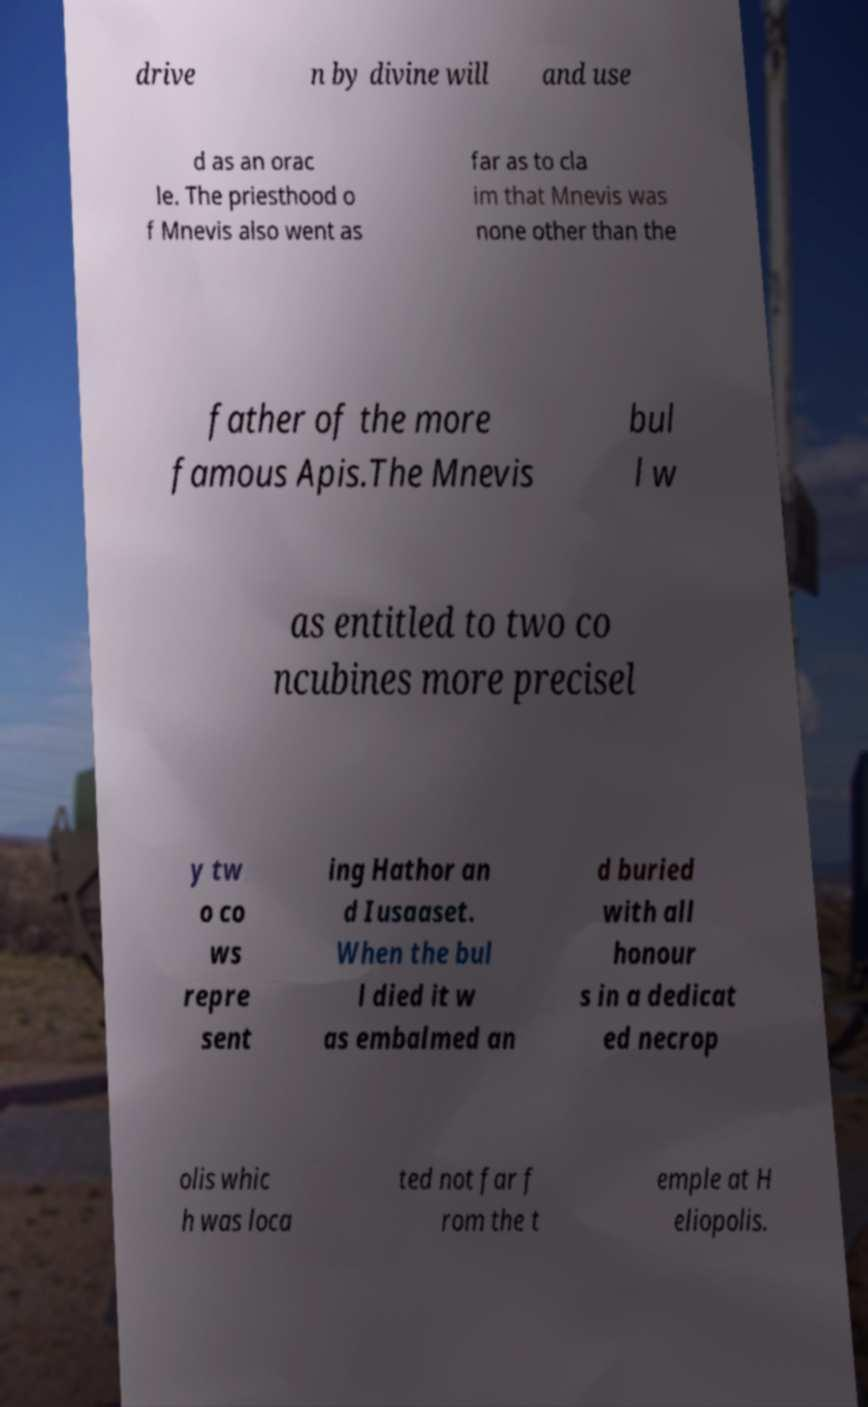Please identify and transcribe the text found in this image. drive n by divine will and use d as an orac le. The priesthood o f Mnevis also went as far as to cla im that Mnevis was none other than the father of the more famous Apis.The Mnevis bul l w as entitled to two co ncubines more precisel y tw o co ws repre sent ing Hathor an d Iusaaset. When the bul l died it w as embalmed an d buried with all honour s in a dedicat ed necrop olis whic h was loca ted not far f rom the t emple at H eliopolis. 